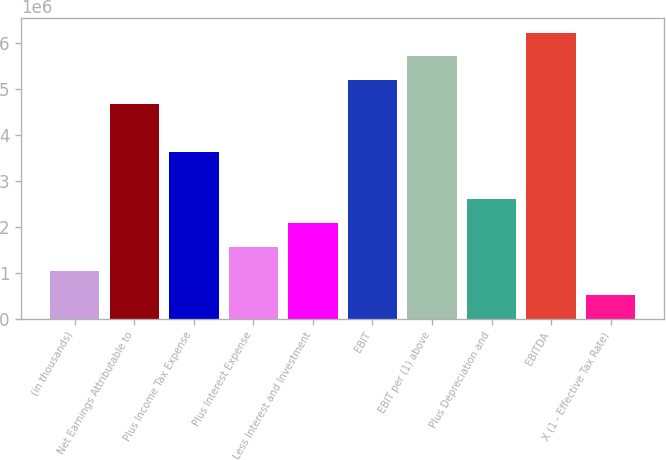Convert chart to OTSL. <chart><loc_0><loc_0><loc_500><loc_500><bar_chart><fcel>(in thousands)<fcel>Net Earnings Attributable to<fcel>Plus Income Tax Expense<fcel>Plus Interest Expense<fcel>Less Interest and Investment<fcel>EBIT<fcel>EBIT per (1) above<fcel>Plus Depreciation and<fcel>EBITDA<fcel>X (1 - Effective Tax Rate)<nl><fcel>1.03719e+06<fcel>4.66732e+06<fcel>3.63014e+06<fcel>1.55578e+06<fcel>2.07437e+06<fcel>5.18591e+06<fcel>5.7045e+06<fcel>2.59296e+06<fcel>6.22309e+06<fcel>518605<nl></chart> 